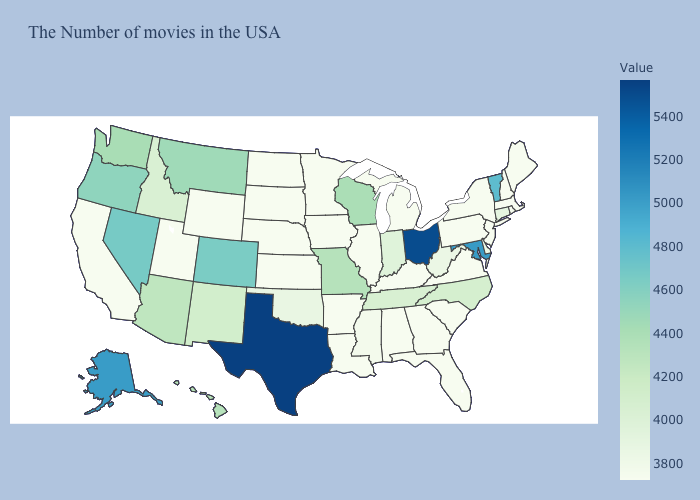Does Rhode Island have the lowest value in the Northeast?
Keep it brief. No. Does Nevada have the highest value in the West?
Short answer required. No. Among the states that border Colorado , does New Mexico have the lowest value?
Keep it brief. No. Among the states that border Maine , which have the lowest value?
Quick response, please. New Hampshire. 